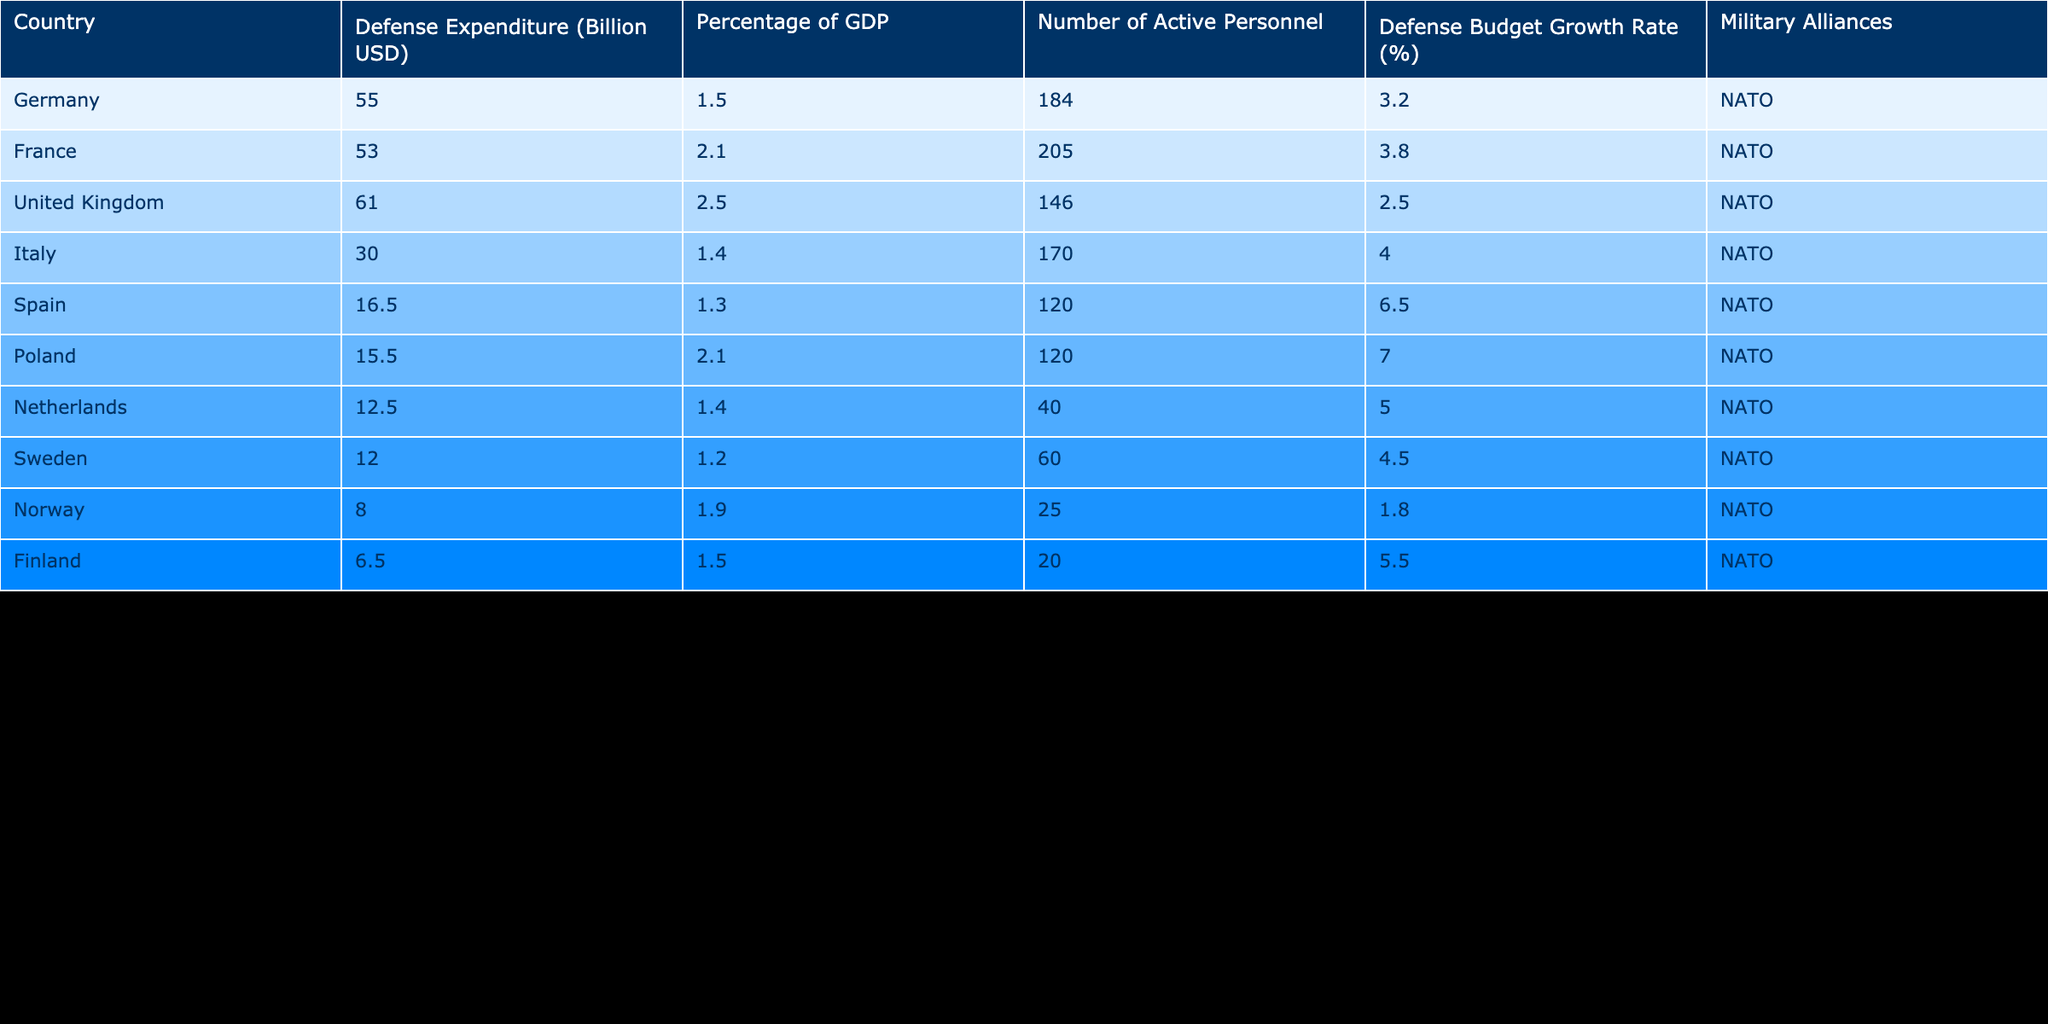What is the highest defense expenditure among European nations in 2022? The defense expenditure values are listed for each country, with Germany at 55.0 billion USD and the United Kingdom at 61.0 billion USD. Comparing these values, the United Kingdom has the highest defense expenditure.
Answer: 61.0 billion USD Which country has the lowest defense expenditure in billion USD? The defense expenditures of the countries are listed, with Spain at 16.5 billion USD and Finland at 6.5 billion USD. Comparing these figures, Finland has the lowest defense expenditure.
Answer: 6.5 billion USD What is the average percentage of GDP spent on defense among the listed countries? To find the average percentage of GDP, we sum the percentages of GDP: 1.5 + 2.1 + 2.5 + 1.4 + 1.3 + 2.1 + 1.4 + 1.2 + 1.9 + 1.5 = 16.5. There are 10 countries, so the average is 16.5/10 = 1.65%.
Answer: 1.65% Is France's defense expenditure greater than that of Italy? France's defense expenditure is 53.0 billion USD while Italy's is 30.0 billion USD. Since 53.0 is greater than 30.0, the statement is true.
Answer: Yes Which country has the highest number of active personnel? The number of active personnel is provided for each country: 184 for Germany, 205 for France, etc. Comparing these figures, France has the highest number at 205 active personnel.
Answer: 205 If we combine the defense expenditures of Spain and Italy, how much do we have? Spain has a defense expenditure of 16.5 billion USD and Italy has 30.0 billion USD. Adding these figures together: 16.5 + 30.0 = 46.5 billion USD.
Answer: 46.5 billion USD Does Poland spend a higher percentage of GDP on defense than Norway? Poland's percentage of GDP spent on defense is 2.1%, while Norway's is 1.9%. Since 2.1% is greater than 1.9%, the statement is true.
Answer: Yes What is the total defense expenditure of all the listed countries? The total can be calculated by summing all the defense expenditures: 55.0 + 53.0 + 61.0 + 30.0 + 16.5 + 15.5 + 12.5 + 12.0 + 8.0 + 6.5 = 269.0 billion USD.
Answer: 269.0 billion USD Which military alliance do most countries belong to? All the listed countries are part of NATO, indicating that NATO is the military alliance for the majority, which is all of them.
Answer: NATO 